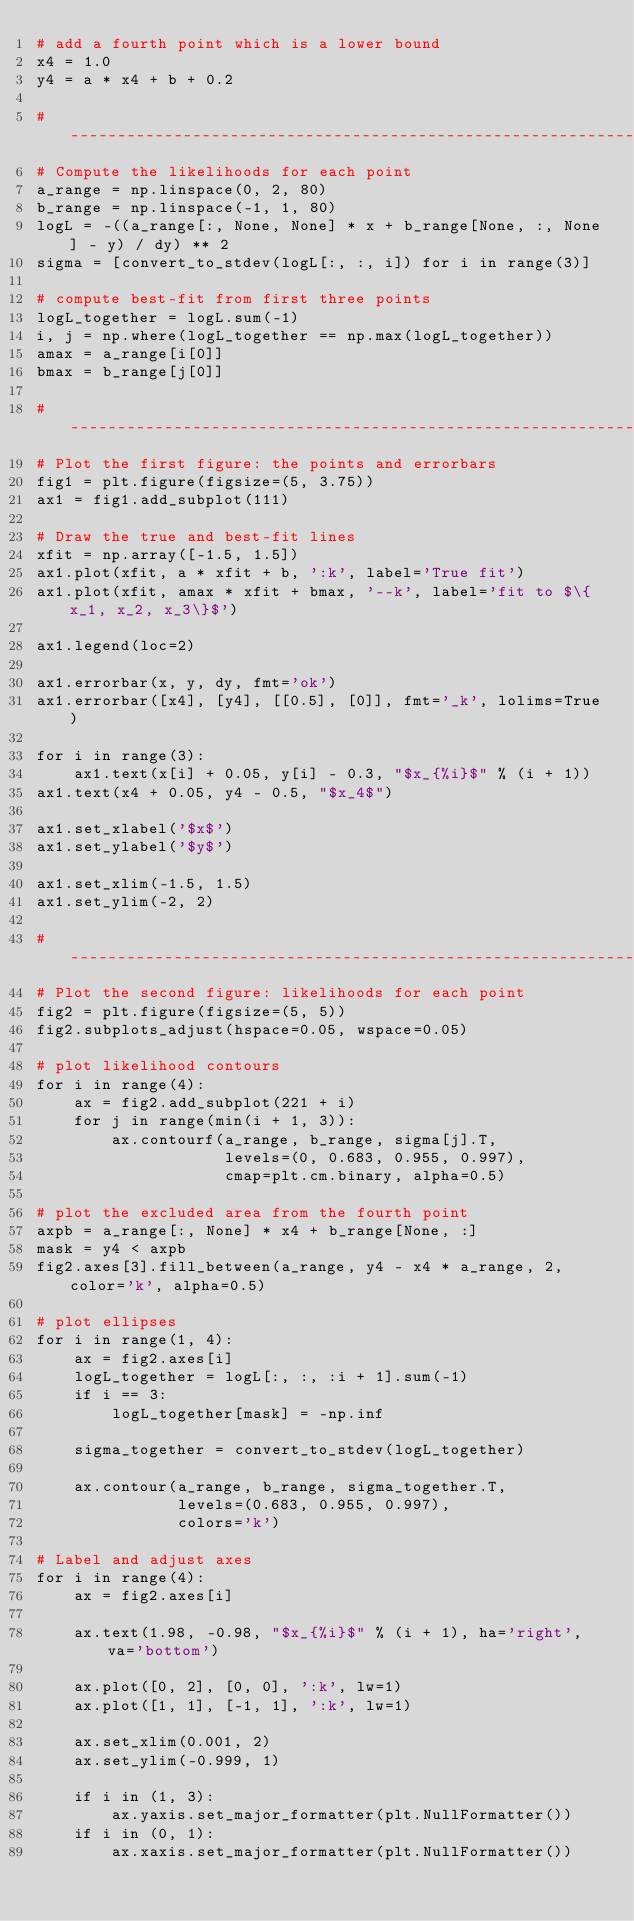<code> <loc_0><loc_0><loc_500><loc_500><_Python_># add a fourth point which is a lower bound
x4 = 1.0
y4 = a * x4 + b + 0.2

#------------------------------------------------------------
# Compute the likelihoods for each point
a_range = np.linspace(0, 2, 80)
b_range = np.linspace(-1, 1, 80)
logL = -((a_range[:, None, None] * x + b_range[None, :, None] - y) / dy) ** 2
sigma = [convert_to_stdev(logL[:, :, i]) for i in range(3)]

# compute best-fit from first three points
logL_together = logL.sum(-1)
i, j = np.where(logL_together == np.max(logL_together))
amax = a_range[i[0]]
bmax = b_range[j[0]]

#------------------------------------------------------------
# Plot the first figure: the points and errorbars
fig1 = plt.figure(figsize=(5, 3.75))
ax1 = fig1.add_subplot(111)

# Draw the true and best-fit lines
xfit = np.array([-1.5, 1.5])
ax1.plot(xfit, a * xfit + b, ':k', label='True fit')
ax1.plot(xfit, amax * xfit + bmax, '--k', label='fit to $\{x_1, x_2, x_3\}$')

ax1.legend(loc=2)

ax1.errorbar(x, y, dy, fmt='ok')
ax1.errorbar([x4], [y4], [[0.5], [0]], fmt='_k', lolims=True)

for i in range(3):
    ax1.text(x[i] + 0.05, y[i] - 0.3, "$x_{%i}$" % (i + 1))
ax1.text(x4 + 0.05, y4 - 0.5, "$x_4$")

ax1.set_xlabel('$x$')
ax1.set_ylabel('$y$')

ax1.set_xlim(-1.5, 1.5)
ax1.set_ylim(-2, 2)

#------------------------------------------------------------
# Plot the second figure: likelihoods for each point
fig2 = plt.figure(figsize=(5, 5))
fig2.subplots_adjust(hspace=0.05, wspace=0.05)

# plot likelihood contours
for i in range(4):
    ax = fig2.add_subplot(221 + i)
    for j in range(min(i + 1, 3)):
        ax.contourf(a_range, b_range, sigma[j].T,
                    levels=(0, 0.683, 0.955, 0.997),
                    cmap=plt.cm.binary, alpha=0.5)

# plot the excluded area from the fourth point
axpb = a_range[:, None] * x4 + b_range[None, :]
mask = y4 < axpb
fig2.axes[3].fill_between(a_range, y4 - x4 * a_range, 2, color='k', alpha=0.5)

# plot ellipses
for i in range(1, 4):
    ax = fig2.axes[i]
    logL_together = logL[:, :, :i + 1].sum(-1)
    if i == 3:
        logL_together[mask] = -np.inf

    sigma_together = convert_to_stdev(logL_together)

    ax.contour(a_range, b_range, sigma_together.T,
               levels=(0.683, 0.955, 0.997),
               colors='k')

# Label and adjust axes
for i in range(4):
    ax = fig2.axes[i]

    ax.text(1.98, -0.98, "$x_{%i}$" % (i + 1), ha='right', va='bottom')

    ax.plot([0, 2], [0, 0], ':k', lw=1)
    ax.plot([1, 1], [-1, 1], ':k', lw=1)

    ax.set_xlim(0.001, 2)
    ax.set_ylim(-0.999, 1)

    if i in (1, 3):
        ax.yaxis.set_major_formatter(plt.NullFormatter())
    if i in (0, 1):
        ax.xaxis.set_major_formatter(plt.NullFormatter())</code> 